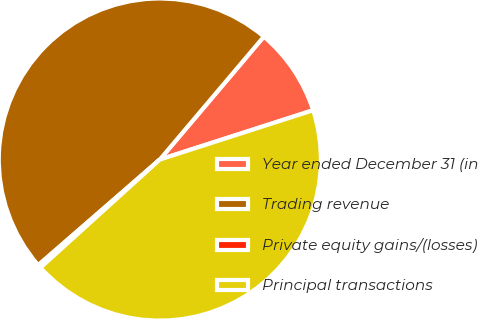Convert chart. <chart><loc_0><loc_0><loc_500><loc_500><pie_chart><fcel>Year ended December 31 (in<fcel>Trading revenue<fcel>Private equity gains/(losses)<fcel>Principal transactions<nl><fcel>8.87%<fcel>47.56%<fcel>0.33%<fcel>43.24%<nl></chart> 